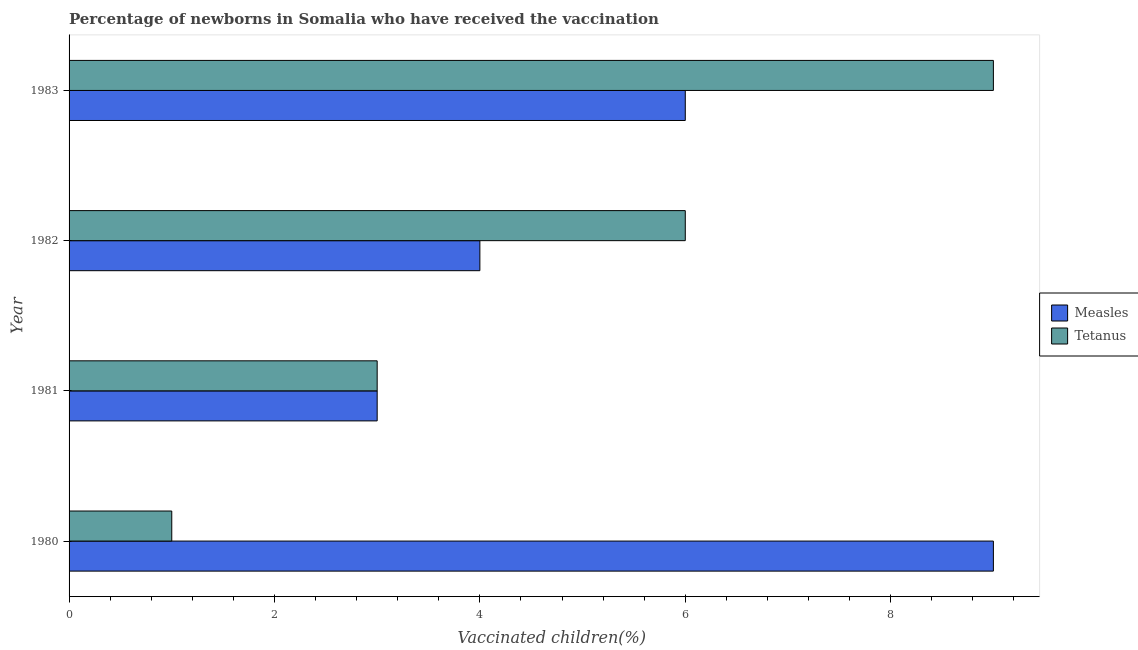How many different coloured bars are there?
Your answer should be very brief. 2. How many groups of bars are there?
Ensure brevity in your answer.  4. How many bars are there on the 3rd tick from the top?
Ensure brevity in your answer.  2. How many bars are there on the 3rd tick from the bottom?
Offer a very short reply. 2. What is the percentage of newborns who received vaccination for tetanus in 1980?
Offer a very short reply. 1. Across all years, what is the maximum percentage of newborns who received vaccination for tetanus?
Keep it short and to the point. 9. Across all years, what is the minimum percentage of newborns who received vaccination for tetanus?
Your answer should be very brief. 1. What is the total percentage of newborns who received vaccination for tetanus in the graph?
Your answer should be very brief. 19. What is the difference between the percentage of newborns who received vaccination for measles in 1980 and that in 1983?
Provide a succinct answer. 3. What is the difference between the percentage of newborns who received vaccination for measles in 1982 and the percentage of newborns who received vaccination for tetanus in 1981?
Provide a short and direct response. 1. What is the average percentage of newborns who received vaccination for tetanus per year?
Ensure brevity in your answer.  4.75. In the year 1983, what is the difference between the percentage of newborns who received vaccination for measles and percentage of newborns who received vaccination for tetanus?
Your answer should be very brief. -3. Is the difference between the percentage of newborns who received vaccination for tetanus in 1981 and 1983 greater than the difference between the percentage of newborns who received vaccination for measles in 1981 and 1983?
Provide a succinct answer. No. What is the difference between the highest and the second highest percentage of newborns who received vaccination for tetanus?
Keep it short and to the point. 3. What is the difference between the highest and the lowest percentage of newborns who received vaccination for tetanus?
Provide a succinct answer. 8. What does the 2nd bar from the top in 1983 represents?
Offer a very short reply. Measles. What does the 1st bar from the bottom in 1980 represents?
Provide a succinct answer. Measles. How many bars are there?
Offer a terse response. 8. Are all the bars in the graph horizontal?
Your answer should be very brief. Yes. What is the difference between two consecutive major ticks on the X-axis?
Your answer should be very brief. 2. Does the graph contain grids?
Ensure brevity in your answer.  No. Where does the legend appear in the graph?
Your answer should be very brief. Center right. How are the legend labels stacked?
Offer a very short reply. Vertical. What is the title of the graph?
Your answer should be very brief. Percentage of newborns in Somalia who have received the vaccination. What is the label or title of the X-axis?
Offer a very short reply. Vaccinated children(%)
. What is the Vaccinated children(%)
 in Tetanus in 1980?
Keep it short and to the point. 1. What is the Vaccinated children(%)
 in Measles in 1981?
Keep it short and to the point. 3. What is the Vaccinated children(%)
 of Tetanus in 1981?
Offer a terse response. 3. What is the Vaccinated children(%)
 of Measles in 1983?
Provide a short and direct response. 6. Across all years, what is the maximum Vaccinated children(%)
 of Tetanus?
Offer a very short reply. 9. Across all years, what is the minimum Vaccinated children(%)
 in Tetanus?
Give a very brief answer. 1. What is the difference between the Vaccinated children(%)
 in Measles in 1980 and that in 1983?
Provide a succinct answer. 3. What is the difference between the Vaccinated children(%)
 in Measles in 1981 and that in 1982?
Give a very brief answer. -1. What is the difference between the Vaccinated children(%)
 of Tetanus in 1981 and that in 1982?
Offer a very short reply. -3. What is the difference between the Vaccinated children(%)
 of Measles in 1982 and that in 1983?
Your answer should be compact. -2. What is the difference between the Vaccinated children(%)
 of Measles in 1980 and the Vaccinated children(%)
 of Tetanus in 1981?
Ensure brevity in your answer.  6. What is the difference between the Vaccinated children(%)
 in Measles in 1980 and the Vaccinated children(%)
 in Tetanus in 1982?
Offer a terse response. 3. What is the difference between the Vaccinated children(%)
 of Measles in 1980 and the Vaccinated children(%)
 of Tetanus in 1983?
Offer a terse response. 0. What is the difference between the Vaccinated children(%)
 in Measles in 1981 and the Vaccinated children(%)
 in Tetanus in 1983?
Offer a terse response. -6. What is the difference between the Vaccinated children(%)
 of Measles in 1982 and the Vaccinated children(%)
 of Tetanus in 1983?
Your answer should be compact. -5. What is the average Vaccinated children(%)
 of Measles per year?
Provide a succinct answer. 5.5. What is the average Vaccinated children(%)
 in Tetanus per year?
Provide a succinct answer. 4.75. In the year 1980, what is the difference between the Vaccinated children(%)
 in Measles and Vaccinated children(%)
 in Tetanus?
Ensure brevity in your answer.  8. In the year 1981, what is the difference between the Vaccinated children(%)
 in Measles and Vaccinated children(%)
 in Tetanus?
Offer a terse response. 0. In the year 1982, what is the difference between the Vaccinated children(%)
 in Measles and Vaccinated children(%)
 in Tetanus?
Your answer should be very brief. -2. In the year 1983, what is the difference between the Vaccinated children(%)
 in Measles and Vaccinated children(%)
 in Tetanus?
Keep it short and to the point. -3. What is the ratio of the Vaccinated children(%)
 of Tetanus in 1980 to that in 1981?
Offer a terse response. 0.33. What is the ratio of the Vaccinated children(%)
 in Measles in 1980 to that in 1982?
Your answer should be very brief. 2.25. What is the ratio of the Vaccinated children(%)
 in Measles in 1980 to that in 1983?
Provide a succinct answer. 1.5. What is the ratio of the Vaccinated children(%)
 in Tetanus in 1981 to that in 1982?
Provide a succinct answer. 0.5. What is the ratio of the Vaccinated children(%)
 of Measles in 1982 to that in 1983?
Your answer should be compact. 0.67. What is the difference between the highest and the lowest Vaccinated children(%)
 in Measles?
Your response must be concise. 6. 